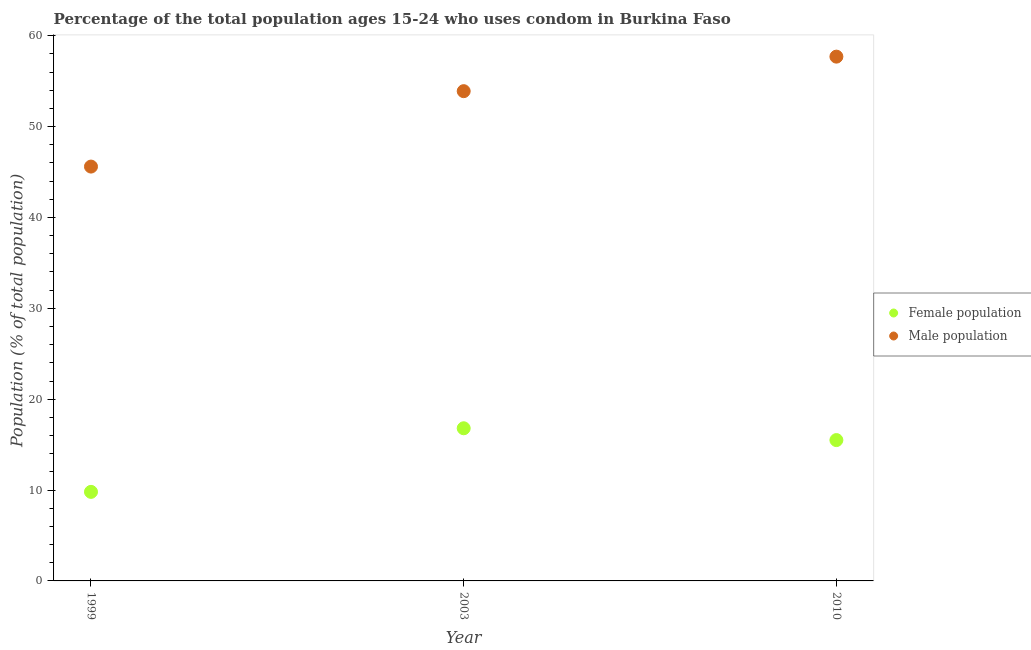How many different coloured dotlines are there?
Make the answer very short. 2. Is the number of dotlines equal to the number of legend labels?
Your response must be concise. Yes. What is the male population in 2003?
Offer a very short reply. 53.9. Across all years, what is the maximum male population?
Ensure brevity in your answer.  57.7. Across all years, what is the minimum male population?
Provide a short and direct response. 45.6. What is the total female population in the graph?
Provide a succinct answer. 42.1. What is the difference between the female population in 1999 and that in 2010?
Offer a terse response. -5.7. What is the difference between the female population in 2010 and the male population in 1999?
Offer a very short reply. -30.1. What is the average female population per year?
Keep it short and to the point. 14.03. In the year 2010, what is the difference between the male population and female population?
Offer a very short reply. 42.2. What is the ratio of the female population in 1999 to that in 2003?
Give a very brief answer. 0.58. Is the female population in 2003 less than that in 2010?
Ensure brevity in your answer.  No. Is the difference between the female population in 1999 and 2003 greater than the difference between the male population in 1999 and 2003?
Offer a very short reply. Yes. What is the difference between the highest and the second highest female population?
Provide a short and direct response. 1.3. Is the sum of the male population in 2003 and 2010 greater than the maximum female population across all years?
Provide a short and direct response. Yes. Is the female population strictly less than the male population over the years?
Provide a succinct answer. Yes. How many dotlines are there?
Give a very brief answer. 2. How many years are there in the graph?
Provide a succinct answer. 3. What is the difference between two consecutive major ticks on the Y-axis?
Offer a very short reply. 10. Are the values on the major ticks of Y-axis written in scientific E-notation?
Your response must be concise. No. Does the graph contain any zero values?
Give a very brief answer. No. Where does the legend appear in the graph?
Ensure brevity in your answer.  Center right. What is the title of the graph?
Make the answer very short. Percentage of the total population ages 15-24 who uses condom in Burkina Faso. What is the label or title of the Y-axis?
Provide a succinct answer. Population (% of total population) . What is the Population (% of total population)  in Female population in 1999?
Offer a terse response. 9.8. What is the Population (% of total population)  in Male population in 1999?
Your answer should be very brief. 45.6. What is the Population (% of total population)  of Female population in 2003?
Your answer should be very brief. 16.8. What is the Population (% of total population)  of Male population in 2003?
Your response must be concise. 53.9. What is the Population (% of total population)  of Male population in 2010?
Your response must be concise. 57.7. Across all years, what is the maximum Population (% of total population)  in Male population?
Provide a short and direct response. 57.7. Across all years, what is the minimum Population (% of total population)  in Female population?
Give a very brief answer. 9.8. Across all years, what is the minimum Population (% of total population)  of Male population?
Ensure brevity in your answer.  45.6. What is the total Population (% of total population)  of Female population in the graph?
Provide a short and direct response. 42.1. What is the total Population (% of total population)  of Male population in the graph?
Your response must be concise. 157.2. What is the difference between the Population (% of total population)  of Male population in 1999 and that in 2003?
Offer a terse response. -8.3. What is the difference between the Population (% of total population)  in Male population in 1999 and that in 2010?
Offer a terse response. -12.1. What is the difference between the Population (% of total population)  in Male population in 2003 and that in 2010?
Your answer should be very brief. -3.8. What is the difference between the Population (% of total population)  of Female population in 1999 and the Population (% of total population)  of Male population in 2003?
Offer a very short reply. -44.1. What is the difference between the Population (% of total population)  of Female population in 1999 and the Population (% of total population)  of Male population in 2010?
Your response must be concise. -47.9. What is the difference between the Population (% of total population)  in Female population in 2003 and the Population (% of total population)  in Male population in 2010?
Offer a very short reply. -40.9. What is the average Population (% of total population)  of Female population per year?
Your answer should be very brief. 14.03. What is the average Population (% of total population)  in Male population per year?
Your answer should be compact. 52.4. In the year 1999, what is the difference between the Population (% of total population)  of Female population and Population (% of total population)  of Male population?
Keep it short and to the point. -35.8. In the year 2003, what is the difference between the Population (% of total population)  in Female population and Population (% of total population)  in Male population?
Ensure brevity in your answer.  -37.1. In the year 2010, what is the difference between the Population (% of total population)  of Female population and Population (% of total population)  of Male population?
Provide a succinct answer. -42.2. What is the ratio of the Population (% of total population)  in Female population in 1999 to that in 2003?
Give a very brief answer. 0.58. What is the ratio of the Population (% of total population)  in Male population in 1999 to that in 2003?
Keep it short and to the point. 0.85. What is the ratio of the Population (% of total population)  of Female population in 1999 to that in 2010?
Your response must be concise. 0.63. What is the ratio of the Population (% of total population)  in Male population in 1999 to that in 2010?
Keep it short and to the point. 0.79. What is the ratio of the Population (% of total population)  of Female population in 2003 to that in 2010?
Make the answer very short. 1.08. What is the ratio of the Population (% of total population)  in Male population in 2003 to that in 2010?
Give a very brief answer. 0.93. What is the difference between the highest and the second highest Population (% of total population)  of Male population?
Provide a short and direct response. 3.8. 